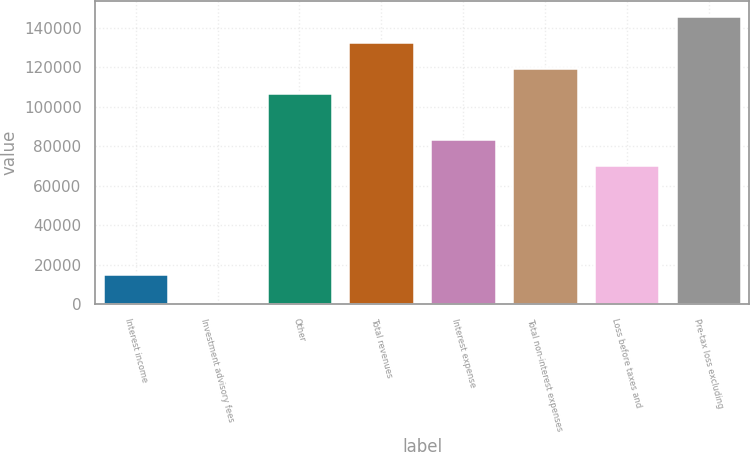Convert chart. <chart><loc_0><loc_0><loc_500><loc_500><bar_chart><fcel>Interest income<fcel>Investment advisory fees<fcel>Other<fcel>Total revenues<fcel>Interest expense<fcel>Total non-interest expenses<fcel>Loss before taxes and<fcel>Pre-tax loss excluding<nl><fcel>15404<fcel>1262<fcel>106735<fcel>132945<fcel>83800.1<fcel>119840<fcel>70695<fcel>146050<nl></chart> 